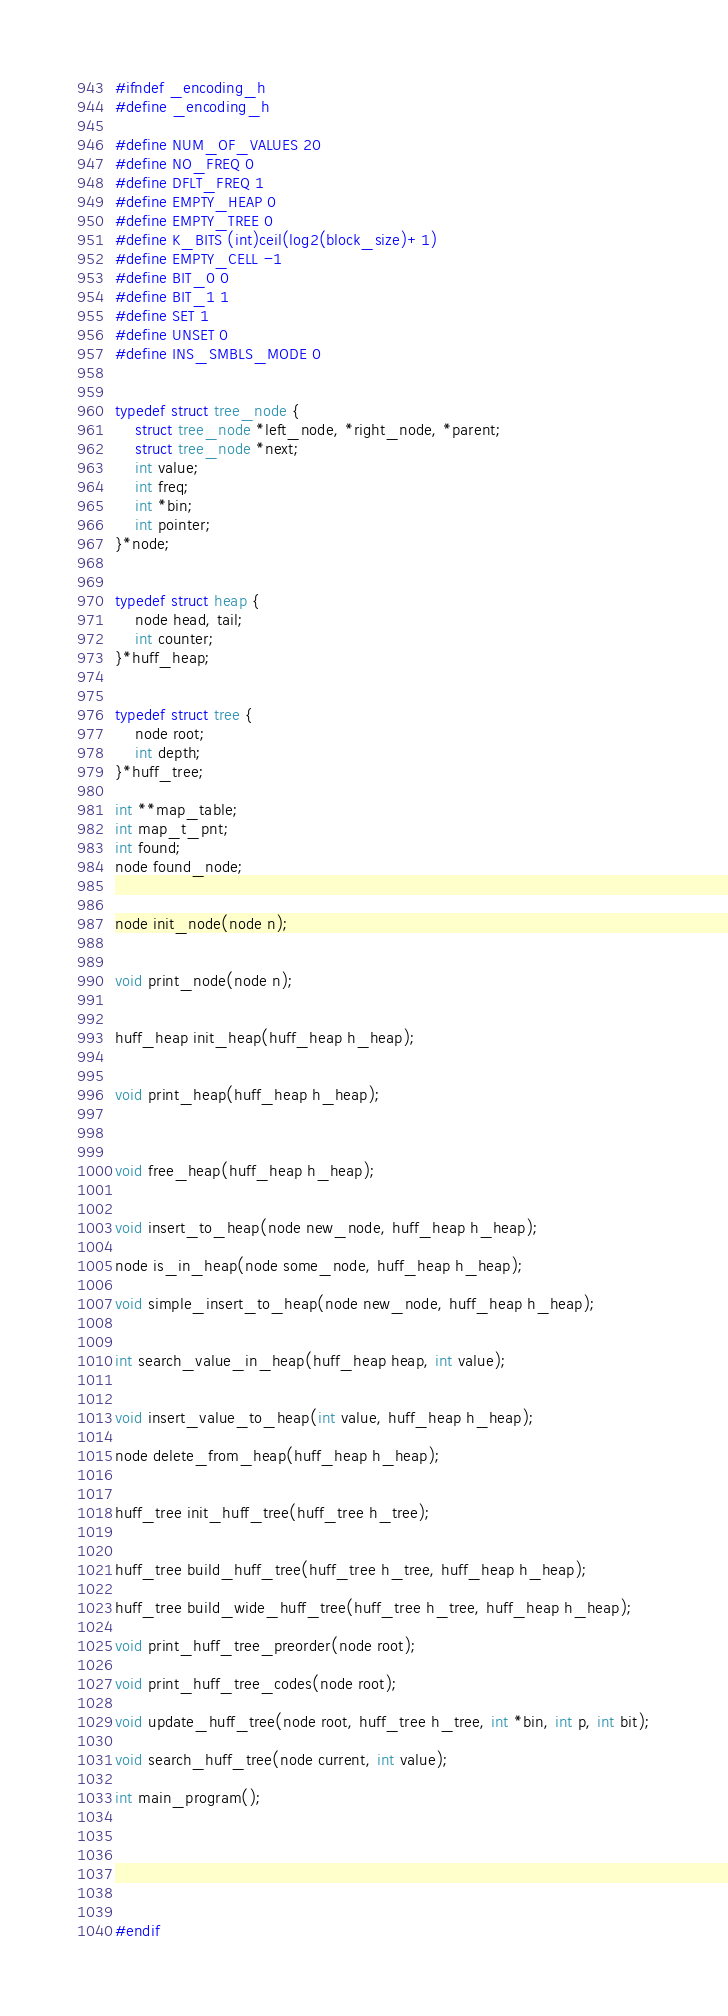Convert code to text. <code><loc_0><loc_0><loc_500><loc_500><_C_>#ifndef _encoding_h
#define _encoding_h

#define NUM_OF_VALUES 20
#define NO_FREQ 0
#define DFLT_FREQ 1
#define EMPTY_HEAP 0
#define EMPTY_TREE 0
#define K_BITS (int)ceil(log2(block_size)+1)
#define EMPTY_CELL -1
#define BIT_0 0
#define BIT_1 1
#define SET 1
#define UNSET 0
#define INS_SMBLS_MODE 0
 

typedef struct tree_node {
    struct tree_node *left_node, *right_node, *parent;
    struct tree_node *next;
    int value;
    int freq;
    int *bin;
    int pointer; 
}*node;


typedef struct heap {
    node head, tail;
    int counter;
}*huff_heap;


typedef struct tree {
    node root;
    int depth;
}*huff_tree;

int **map_table;
int map_t_pnt;
int found;
node found_node;


node init_node(node n);


void print_node(node n);


huff_heap init_heap(huff_heap h_heap);


void print_heap(huff_heap h_heap);



void free_heap(huff_heap h_heap);


void insert_to_heap(node new_node, huff_heap h_heap);

node is_in_heap(node some_node, huff_heap h_heap);

void simple_insert_to_heap(node new_node, huff_heap h_heap);


int search_value_in_heap(huff_heap heap, int value);


void insert_value_to_heap(int value, huff_heap h_heap);

node delete_from_heap(huff_heap h_heap);


huff_tree init_huff_tree(huff_tree h_tree);


huff_tree build_huff_tree(huff_tree h_tree, huff_heap h_heap); 

huff_tree build_wide_huff_tree(huff_tree h_tree, huff_heap h_heap);

void print_huff_tree_preorder(node root);

void print_huff_tree_codes(node root);

void update_huff_tree(node root, huff_tree h_tree, int *bin, int p, int bit);

void search_huff_tree(node current, int value);

int main_program();






#endif
</code> 